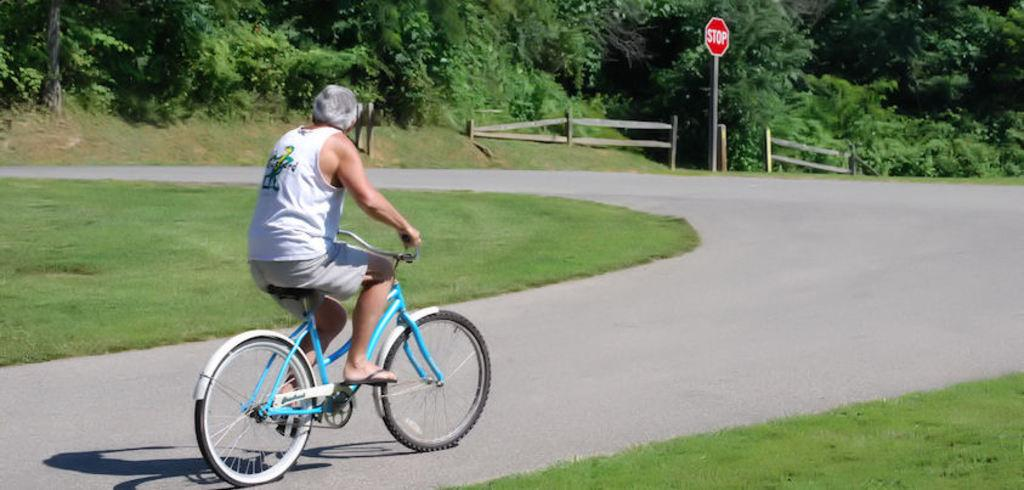What is the person in the image doing? The person is riding a bicycle. How is the person controlling the bicycle? The person is holding the handle of the bicycle. What can be seen in the background of the image? There is a tree, the sky, a road, and a stop board visible in the background of the image. How many kittens are sitting on the stop board in the image? There are no kittens present in the image; the stop board is the only object visible in that part of the image. 